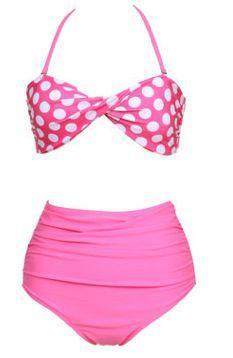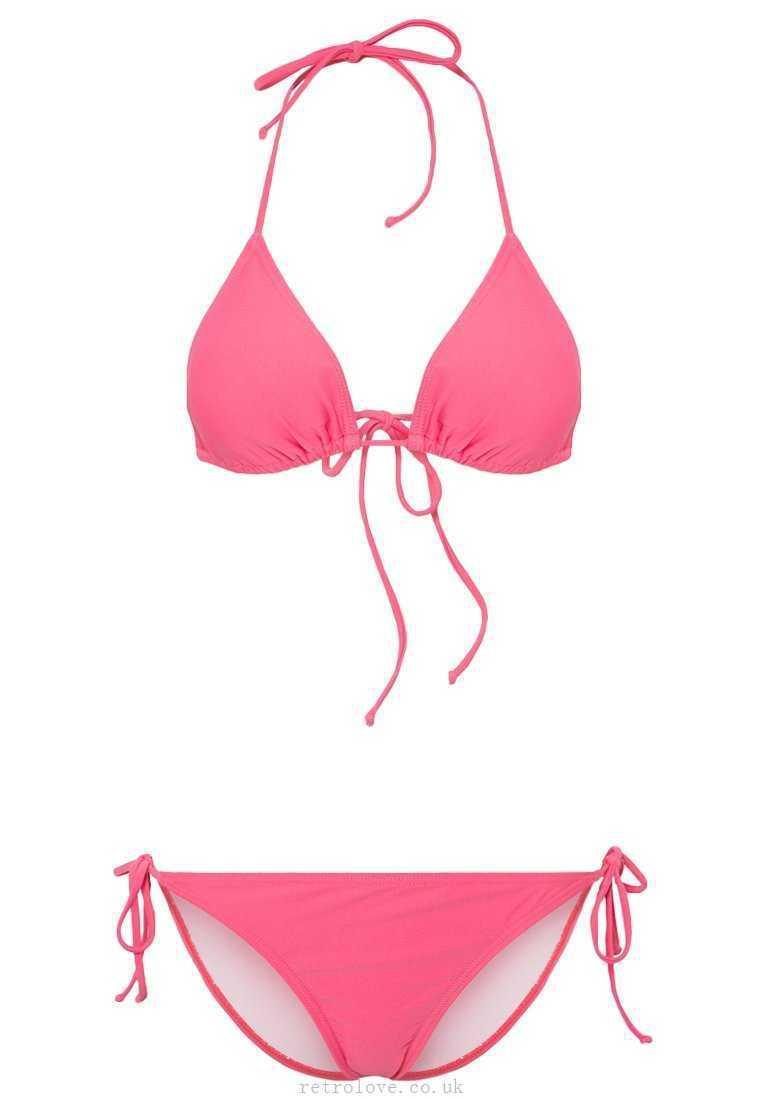The first image is the image on the left, the second image is the image on the right. Given the left and right images, does the statement "There is not less than one mannequin" hold true? Answer yes or no. No. 